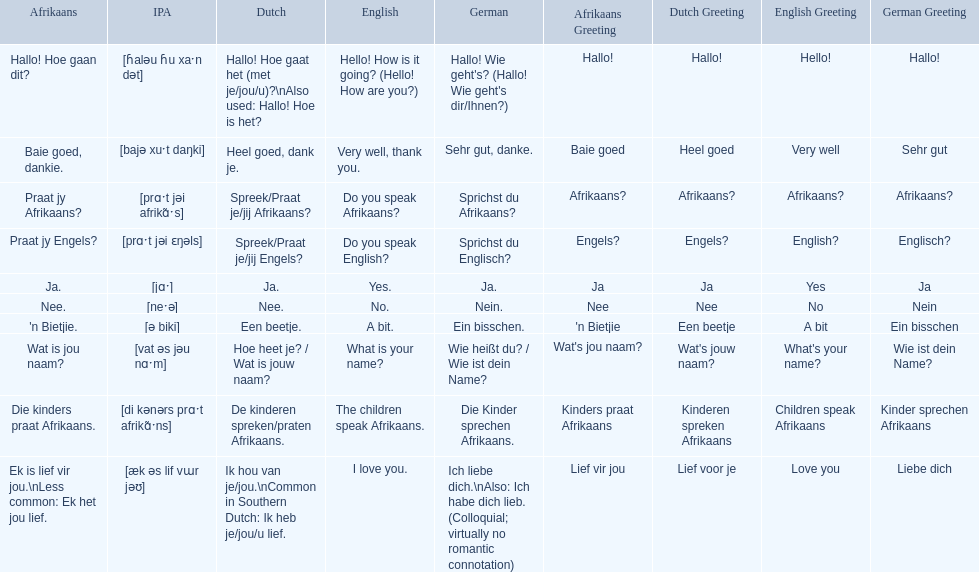What are the afrikaans phrases? Hallo! Hoe gaan dit?, Baie goed, dankie., Praat jy Afrikaans?, Praat jy Engels?, Ja., Nee., 'n Bietjie., Wat is jou naam?, Die kinders praat Afrikaans., Ek is lief vir jou.\nLess common: Ek het jou lief. For die kinders praat afrikaans, what are the translations? De kinderen spreken/praten Afrikaans., The children speak Afrikaans., Die Kinder sprechen Afrikaans. Which one is the german translation? Die Kinder sprechen Afrikaans. 